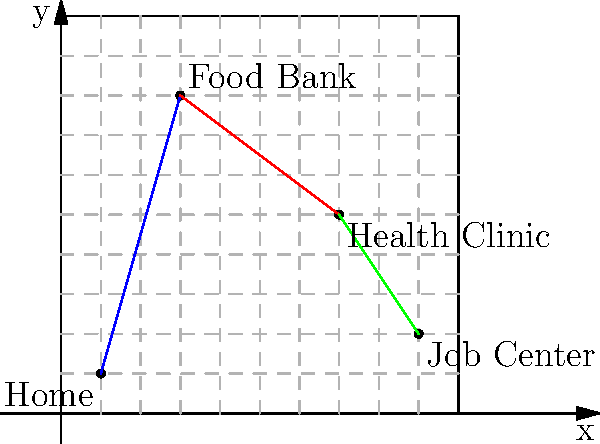A refugee family needs to visit three support services in their new city: a food bank, a health clinic, and a job center. The locations are plotted on a coordinate grid where each unit represents 1 km. The family starts from home at (1,1) and plans to visit the services in this order: food bank, health clinic, and job center. 

Given:
- Food Bank: (3,8)
- Health Clinic: (7,5)
- Job Center: (9,2)

Calculate the total distance traveled by the family if they take the most direct route between each location. Round your answer to the nearest tenth of a kilometer. To solve this problem, we need to calculate the distance between each pair of points and sum them up. We'll use the distance formula: $d = \sqrt{(x_2-x_1)^2 + (y_2-y_1)^2}$

1. Distance from Home to Food Bank:
   $d_1 = \sqrt{(3-1)^2 + (8-1)^2} = \sqrt{4 + 49} = \sqrt{53} \approx 7.28$ km

2. Distance from Food Bank to Health Clinic:
   $d_2 = \sqrt{(7-3)^2 + (5-8)^2} = \sqrt{16 + 9} = \sqrt{25} = 5$ km

3. Distance from Health Clinic to Job Center:
   $d_3 = \sqrt{(9-7)^2 + (2-5)^2} = \sqrt{4 + 9} = \sqrt{13} \approx 3.61$ km

4. Total distance:
   $d_{total} = d_1 + d_2 + d_3 = 7.28 + 5 + 3.61 = 15.89$ km

Rounding to the nearest tenth: 15.9 km
Answer: 15.9 km 